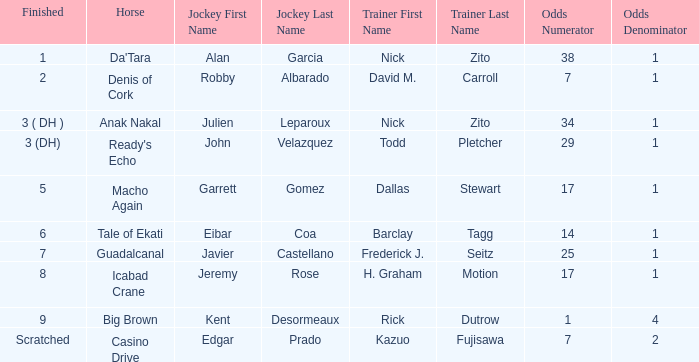Which horse came in 8th place? Icabad Crane. 